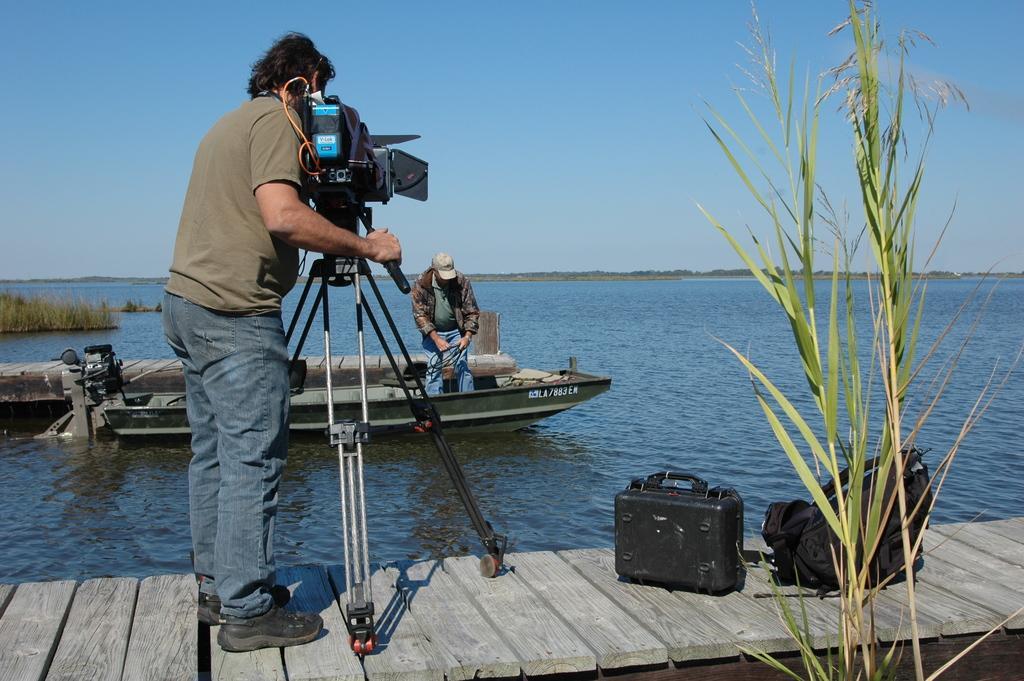In one or two sentences, can you explain what this image depicts? This images clicked outside where there is a water in the middle of the image and there is some plant on the right side, there is a wooden Bridge where a man is standing in the middle he is wearing sand color T shirt and blue color jeans with black shoes. He is holding camera in his hand ,in front of him there is a boat in that both a person is standing he is wearing a jacket and blue jeans , he is also wearing a cap, there is grass on the left side corner, there is Sky on the top. 